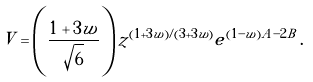Convert formula to latex. <formula><loc_0><loc_0><loc_500><loc_500>V = \left ( \frac { 1 + 3 w } { \sqrt { 6 } } \right ) z ^ { ( 1 + 3 w ) / ( 3 + 3 w ) } e ^ { ( 1 - w ) A - 2 B } \, .</formula> 